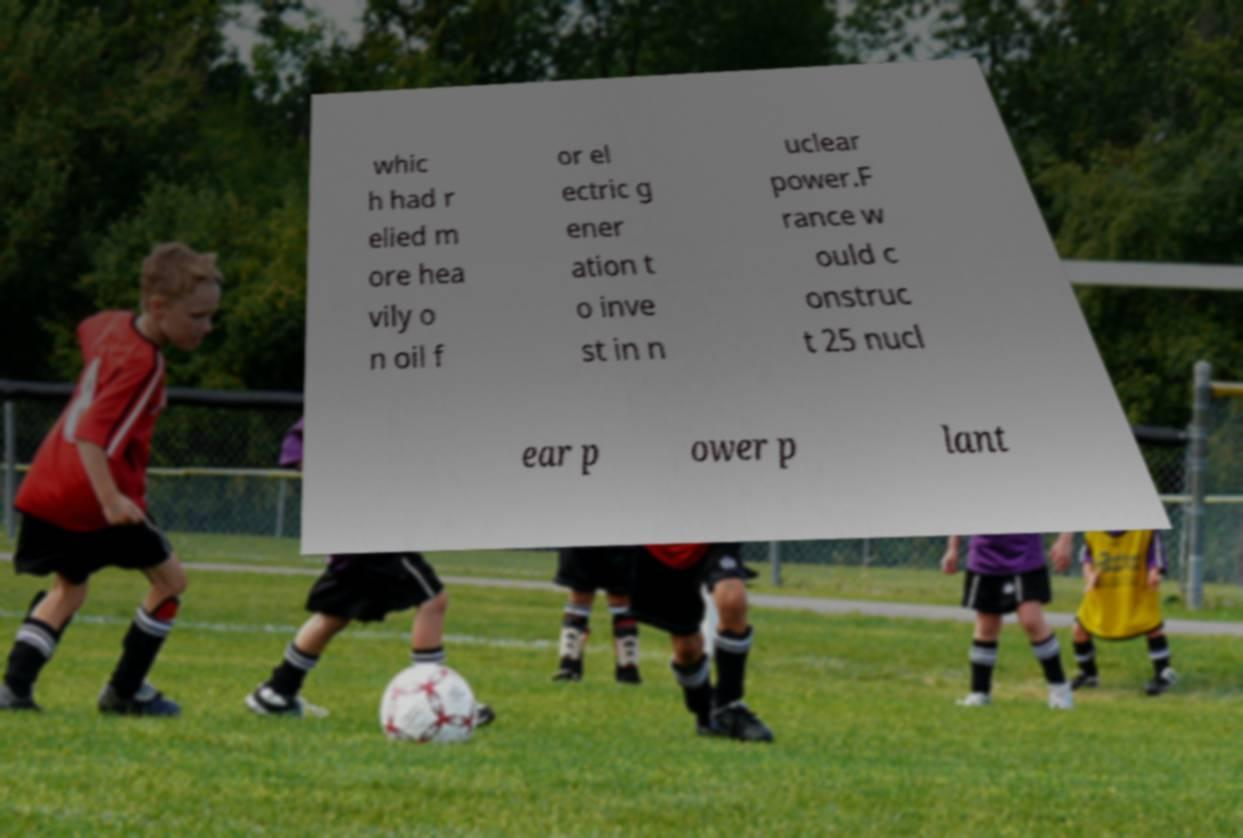Could you assist in decoding the text presented in this image and type it out clearly? whic h had r elied m ore hea vily o n oil f or el ectric g ener ation t o inve st in n uclear power.F rance w ould c onstruc t 25 nucl ear p ower p lant 